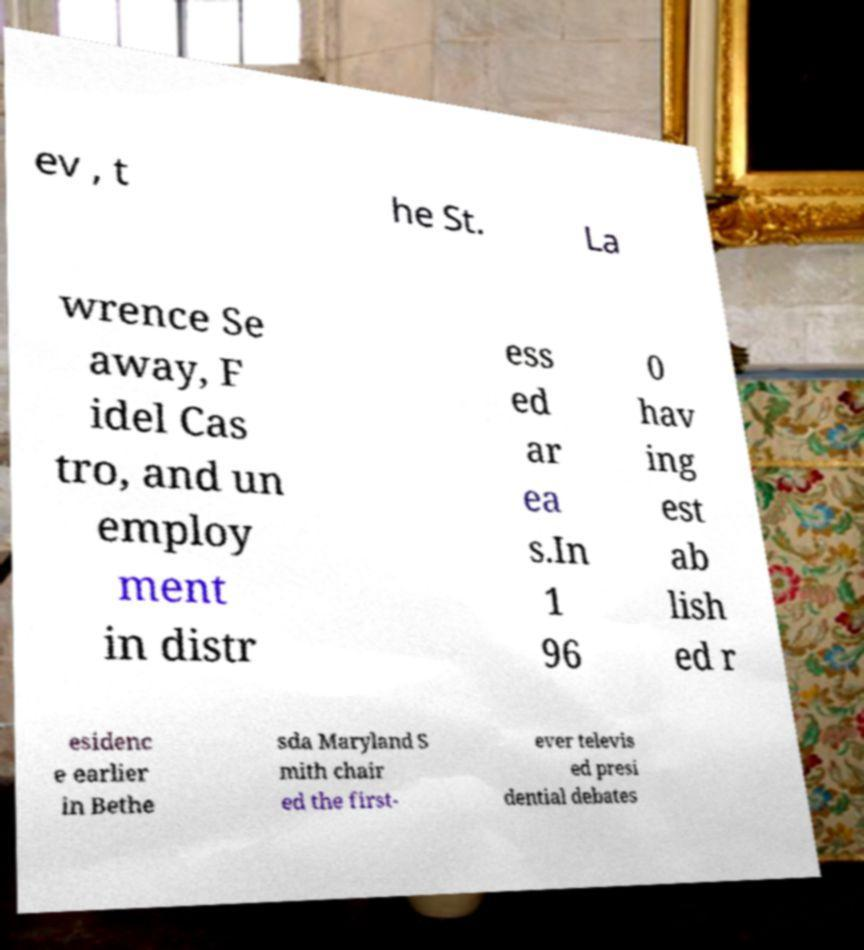Could you assist in decoding the text presented in this image and type it out clearly? ev , t he St. La wrence Se away, F idel Cas tro, and un employ ment in distr ess ed ar ea s.In 1 96 0 hav ing est ab lish ed r esidenc e earlier in Bethe sda Maryland S mith chair ed the first- ever televis ed presi dential debates 